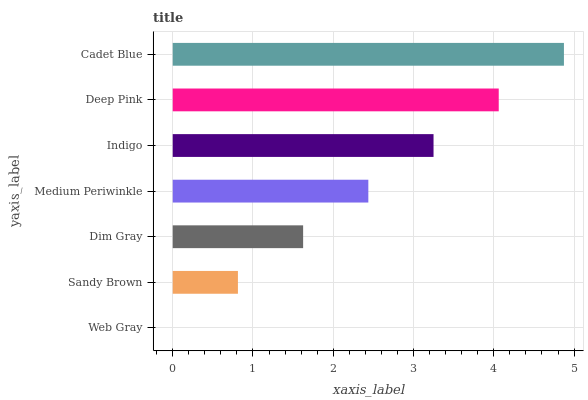Is Web Gray the minimum?
Answer yes or no. Yes. Is Cadet Blue the maximum?
Answer yes or no. Yes. Is Sandy Brown the minimum?
Answer yes or no. No. Is Sandy Brown the maximum?
Answer yes or no. No. Is Sandy Brown greater than Web Gray?
Answer yes or no. Yes. Is Web Gray less than Sandy Brown?
Answer yes or no. Yes. Is Web Gray greater than Sandy Brown?
Answer yes or no. No. Is Sandy Brown less than Web Gray?
Answer yes or no. No. Is Medium Periwinkle the high median?
Answer yes or no. Yes. Is Medium Periwinkle the low median?
Answer yes or no. Yes. Is Web Gray the high median?
Answer yes or no. No. Is Dim Gray the low median?
Answer yes or no. No. 